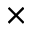Convert formula to latex. <formula><loc_0><loc_0><loc_500><loc_500>\times</formula> 